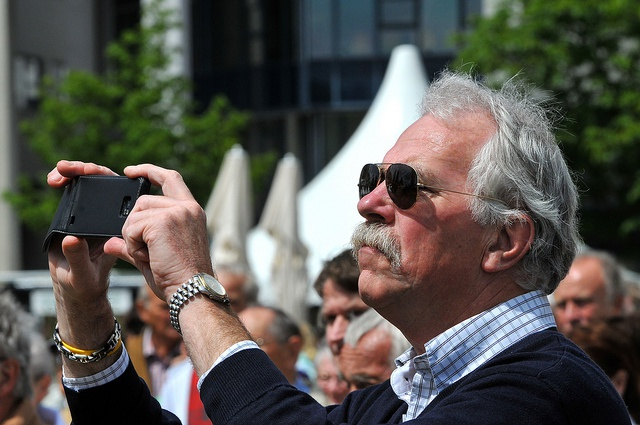Describe the objects in this image and their specific colors. I can see people in darkgray, black, maroon, gray, and lightpink tones, people in darkgray, brown, maroon, gray, and black tones, cell phone in darkgray, black, gray, and darkblue tones, people in darkgray, black, maroon, and gray tones, and people in darkgray, brown, maroon, and lightpink tones in this image. 